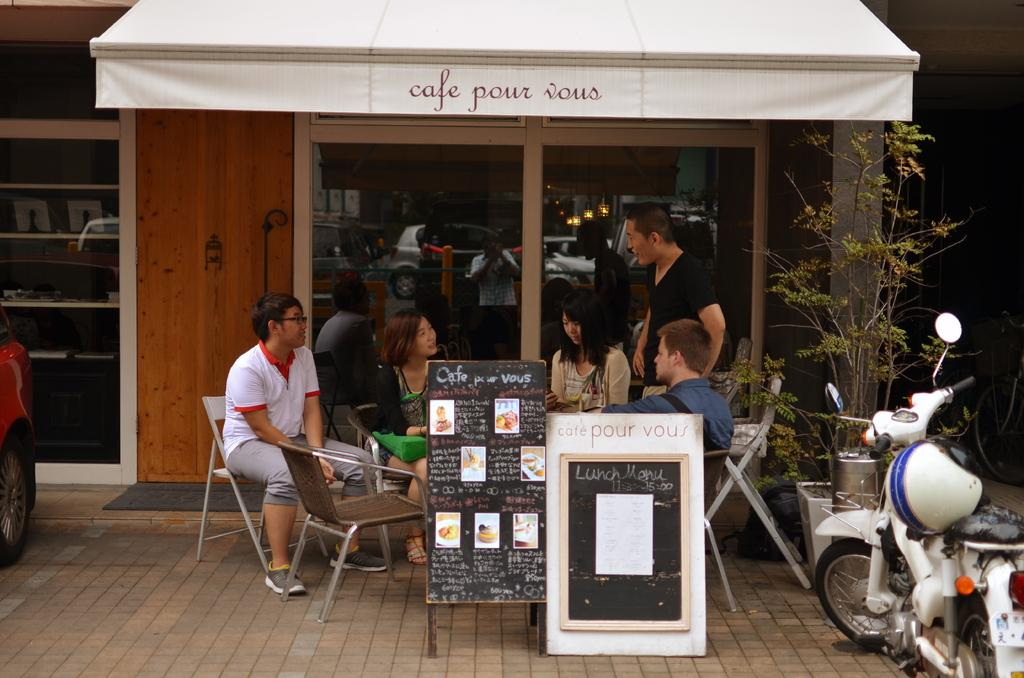What type of structure is visible in the image? There is a house in the image. What color is the cloth that can be seen in the image? The cloth in the image is white. What is hanging in the image? There is a banner in the image. What type of vehicle is present in the image? There is a motorcycle in the image. What type of plant is visible in the image? There is a plant in the image. What type of furniture is present in the image? There are chairs in the image. How many people are in the image? There is a group of people in the image. What type of reflection can be seen in the image? There are reflections of cars and lights in the image. What type of quilt is being used as a tablecloth in the image? There is no quilt present in the image; it is a white cloth. What type of appliance is being used by the group of people in the image? There is no appliance mentioned or visible in the image. 